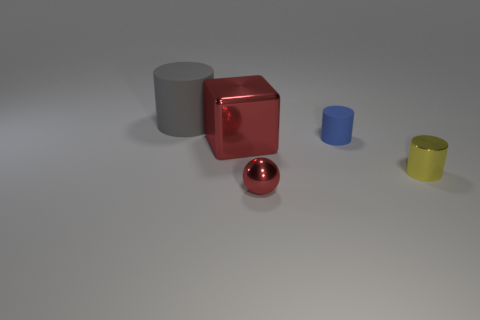Are there any yellow metal objects that are in front of the metal thing behind the yellow metal object to the right of the gray thing? Yes, in front of the silver cylinder, located behind the yellow metal cylinder to the right of the gray cylinder, there is a yellow metal object that appears to be a smaller cylinder. 